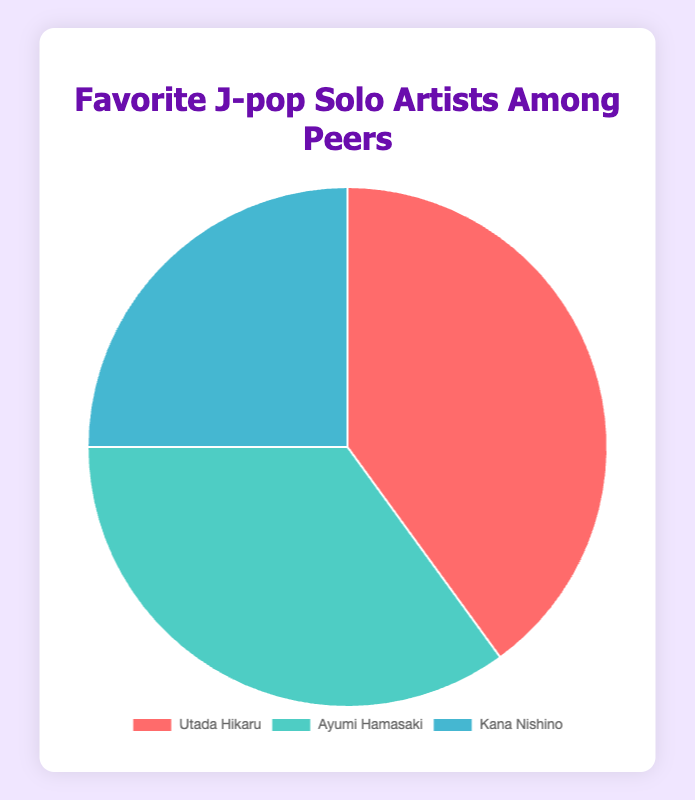What's the total percentage of peers who prefer either Ayumi Hamasaki or Kana Nishino? Add the percentages for Ayumi Hamasaki and Kana Nishino: 35% + 25% = 60%
Answer: 60% Which solo artist has the highest preference among peers? Compare the percentages: Utada Hikaru (40%), Ayumi Hamasaki (35%), Kana Nishino (25%). Utada Hikaru has the highest percentage.
Answer: Utada Hikaru What is the percentage difference between the most and least preferred artists? Subtract the percentage of the least preferred artist (Kana Nishino, 25%) from the most preferred artist (Utada Hikaru, 40%): 40% - 25% = 15%
Answer: 15% If you combine the preferences of Utada Hikaru and Ayumi Hamasaki, what percentage of the total do they make up? Add the percentages of Utada Hikaru and Ayumi Hamasaki: 40% + 35% = 75%
Answer: 75% Which artist represents the smallest section of the pie chart and what is their percentage? Identify the artist with the lowest percentage: Kana Nishino with 25%
Answer: Kana Nishino, 25% True or False: More than half of the peers prefer either Utada Hikaru or Kana Nishino. Add the percentages of Utada Hikaru and Kana Nishino: 40% + 25% = 65%. Since 65% is more than 50%, this statement is true.
Answer: True By how much does Utada Hikaru's preference exceed Ayumi Hamasaki's? Subtract Ayumi Hamasaki's percentage (35%) from Utada Hikaru's percentage (40%): 40% - 35% = 5%
Answer: 5% Which color represents Kana Nishino in the pie chart? Identify the colors associated with each segment: Kana Nishino is represented by blue.
Answer: Blue What is the average percentage preference of all the artists? Add all the percentages and divide by the number of artists: (40% + 35% + 25%) / 3 = 100% / 3 ≈ 33.33%
Answer: 33.33% Based on the chart, which two artists combined have a preference less than 70%? Combine percentages of various artists:
- Ayumi Hamasaki and Kana Nishino: 35% + 25% = 60%
- Utada Hikaru and Kana Nishino: 40% + 25% = 65%
Both combinations are under 70%.
Answer: Ayumi Hamasaki and Kana Nishino 